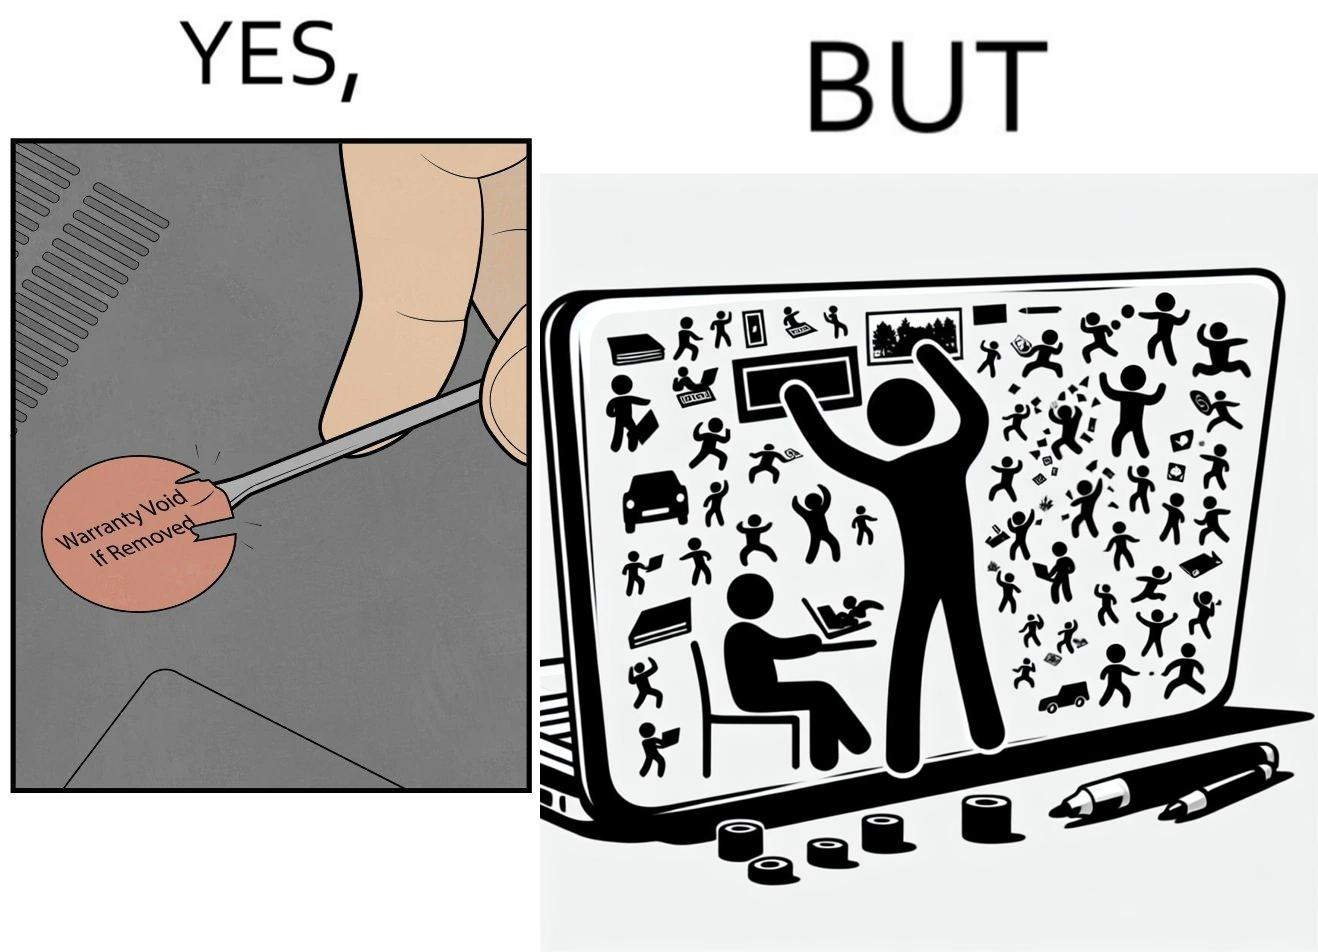What is shown in this image? The images are funny since it shows how an user chooses to remove a rather important warranty sticker because it does not look good, but chooses to fill his laptop with useless stickers just to decorate the laptop 